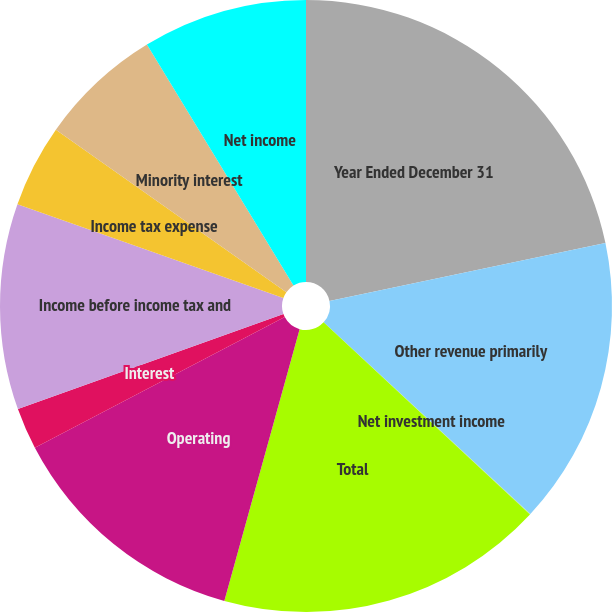<chart> <loc_0><loc_0><loc_500><loc_500><pie_chart><fcel>Year Ended December 31<fcel>Other revenue primarily<fcel>Net investment income<fcel>Total<fcel>Operating<fcel>Interest<fcel>Income before income tax and<fcel>Income tax expense<fcel>Minority interest<fcel>Net income<nl><fcel>21.7%<fcel>15.2%<fcel>0.03%<fcel>17.37%<fcel>13.03%<fcel>2.2%<fcel>10.87%<fcel>4.37%<fcel>6.53%<fcel>8.7%<nl></chart> 